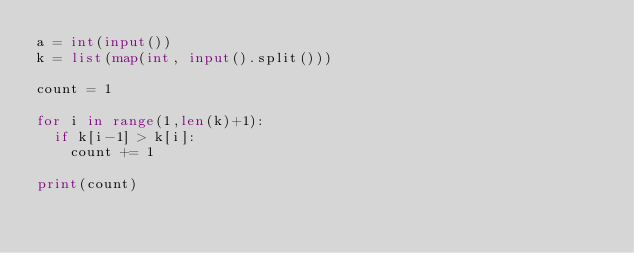<code> <loc_0><loc_0><loc_500><loc_500><_Python_>a = int(input())
k = list(map(int, input().split()))

count = 1

for i in range(1,len(k)+1):
  if k[i-1] > k[i]:
    count += 1

print(count)
</code> 